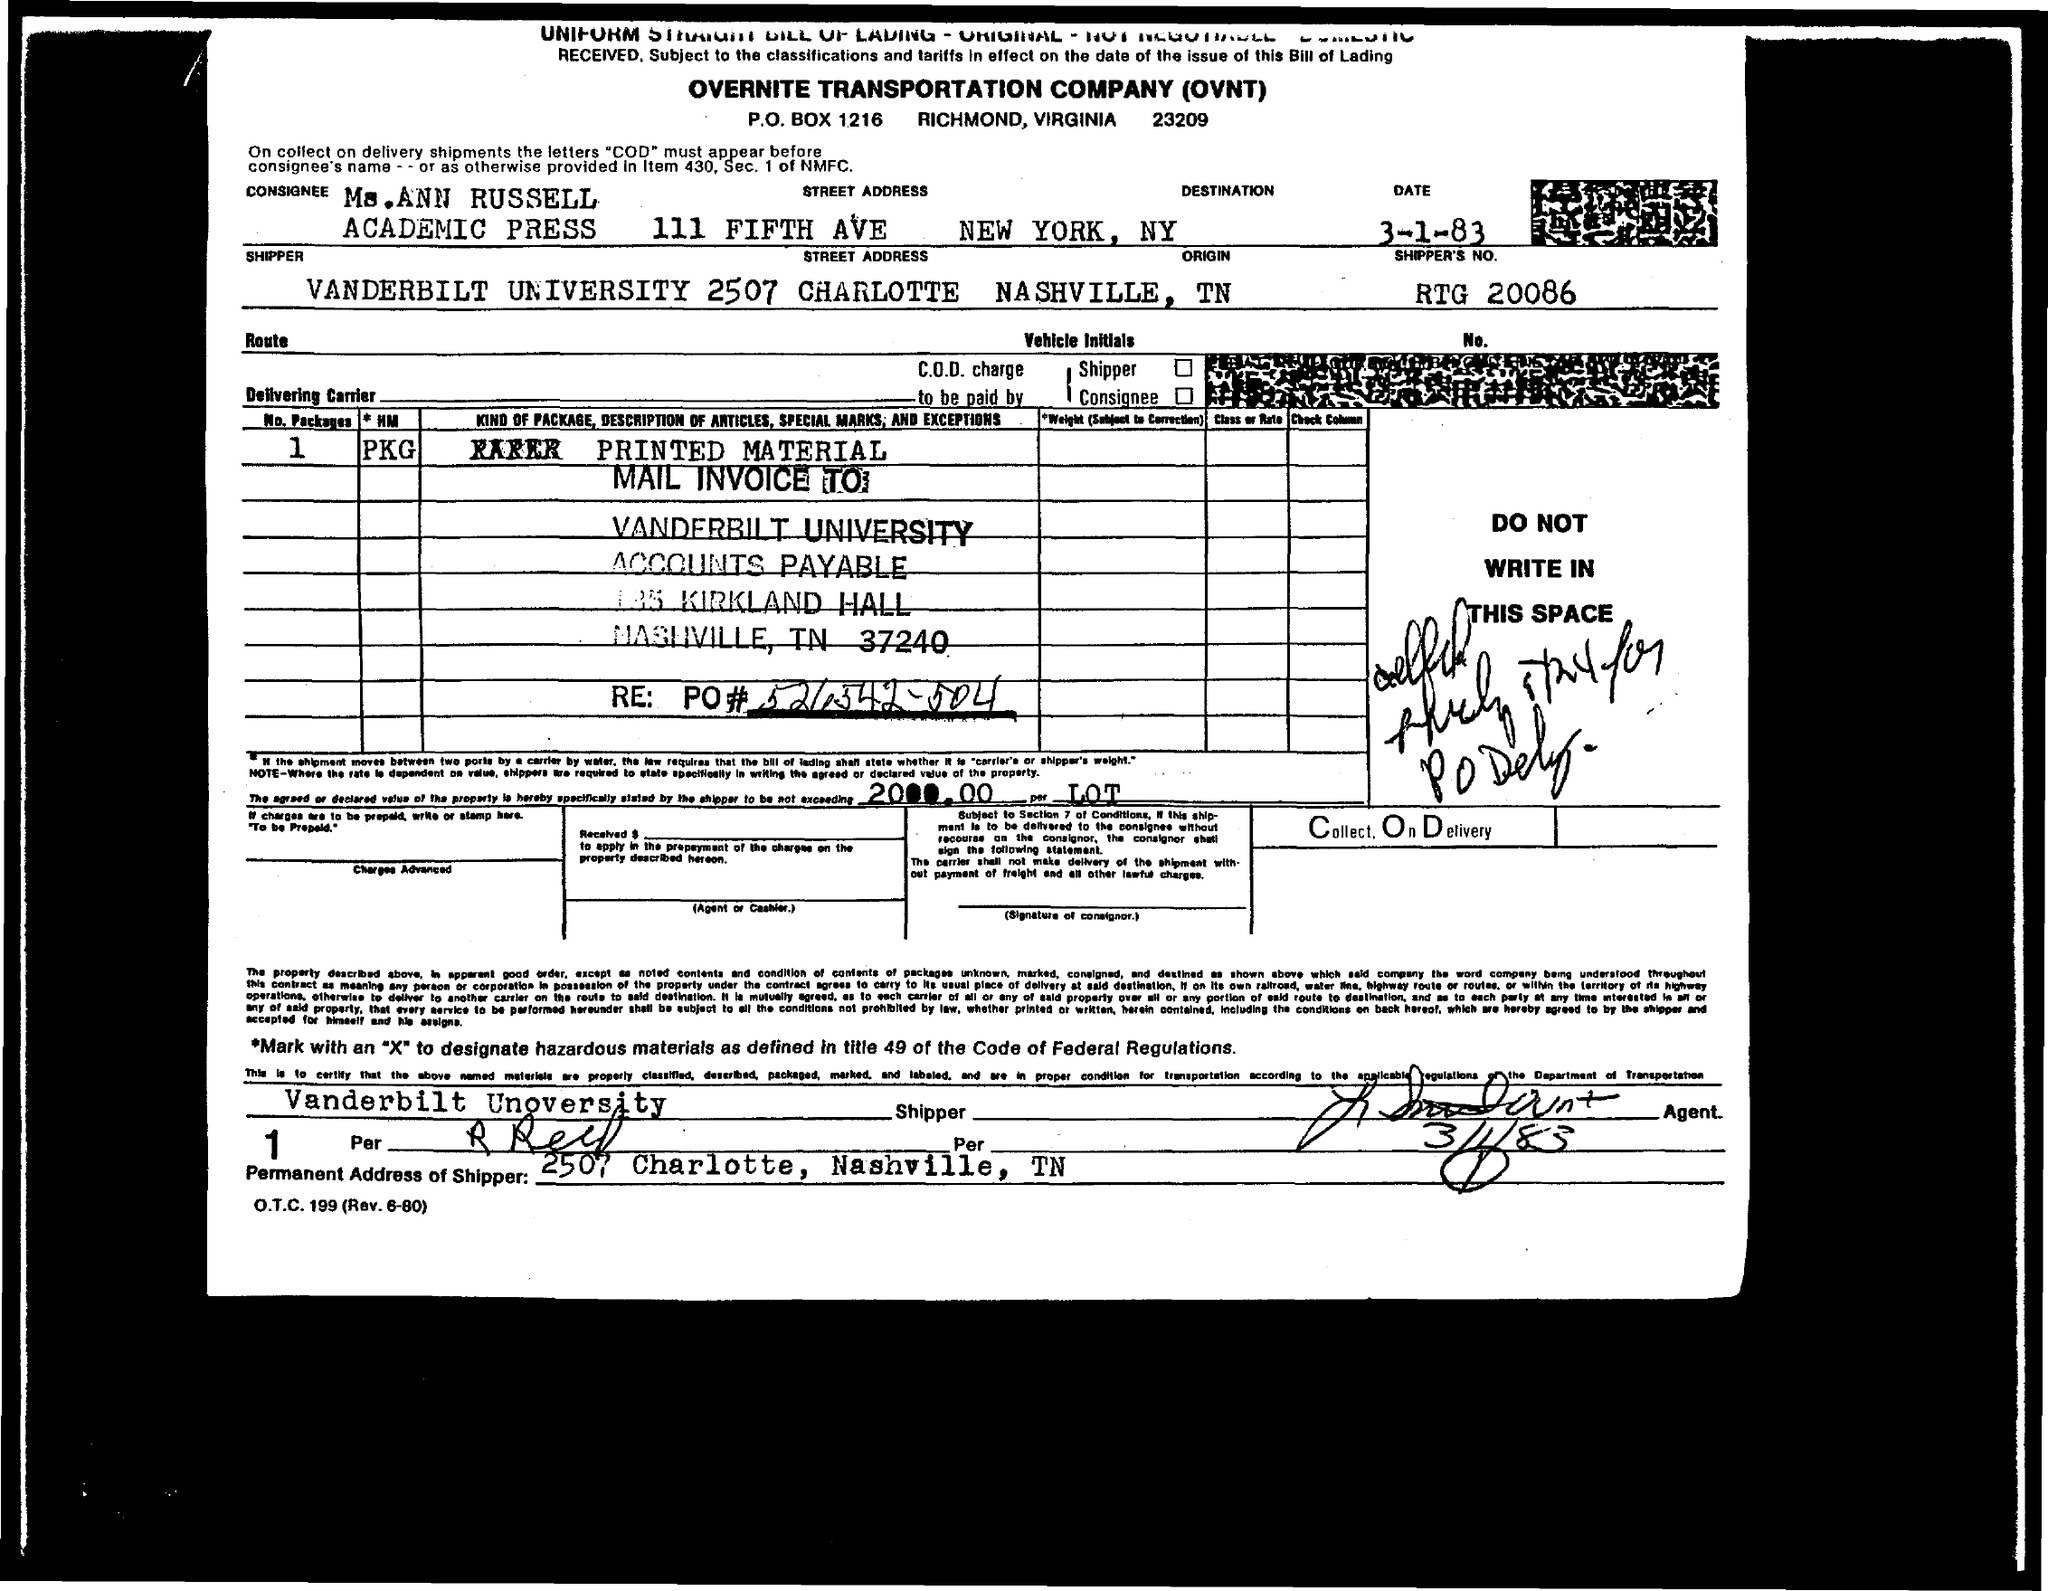Indicate a few pertinent items in this graphic. The fullform of OVNT is Overnite Transportation Company. The P.O. BOX number is 1216. 